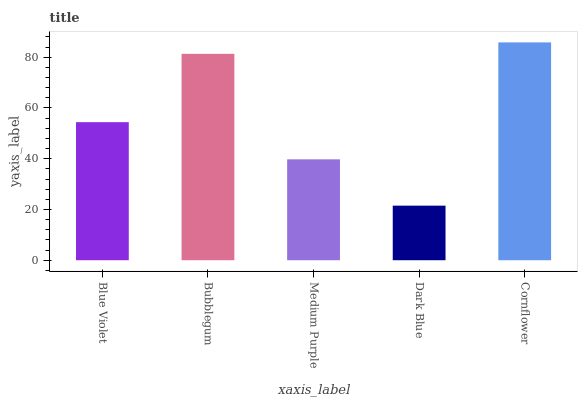Is Bubblegum the minimum?
Answer yes or no. No. Is Bubblegum the maximum?
Answer yes or no. No. Is Bubblegum greater than Blue Violet?
Answer yes or no. Yes. Is Blue Violet less than Bubblegum?
Answer yes or no. Yes. Is Blue Violet greater than Bubblegum?
Answer yes or no. No. Is Bubblegum less than Blue Violet?
Answer yes or no. No. Is Blue Violet the high median?
Answer yes or no. Yes. Is Blue Violet the low median?
Answer yes or no. Yes. Is Bubblegum the high median?
Answer yes or no. No. Is Bubblegum the low median?
Answer yes or no. No. 